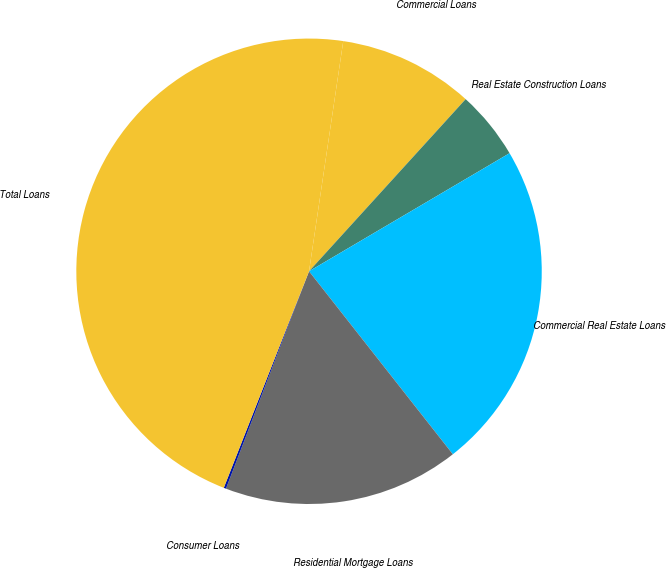<chart> <loc_0><loc_0><loc_500><loc_500><pie_chart><fcel>Commercial Loans<fcel>Real Estate Construction Loans<fcel>Commercial Real Estate Loans<fcel>Residential Mortgage Loans<fcel>Consumer Loans<fcel>Total Loans<nl><fcel>9.4%<fcel>4.78%<fcel>22.87%<fcel>16.41%<fcel>0.16%<fcel>46.38%<nl></chart> 